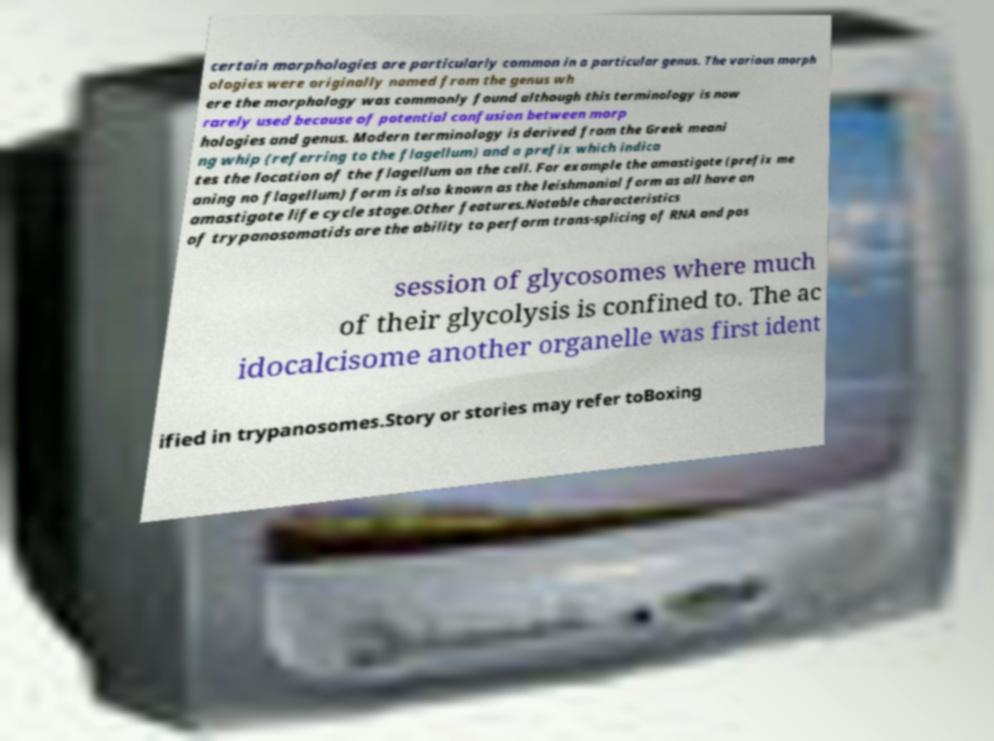I need the written content from this picture converted into text. Can you do that? certain morphologies are particularly common in a particular genus. The various morph ologies were originally named from the genus wh ere the morphology was commonly found although this terminology is now rarely used because of potential confusion between morp hologies and genus. Modern terminology is derived from the Greek meani ng whip (referring to the flagellum) and a prefix which indica tes the location of the flagellum on the cell. For example the amastigote (prefix me aning no flagellum) form is also known as the leishmanial form as all have an amastigote life cycle stage.Other features.Notable characteristics of trypanosomatids are the ability to perform trans-splicing of RNA and pos session of glycosomes where much of their glycolysis is confined to. The ac idocalcisome another organelle was first ident ified in trypanosomes.Story or stories may refer toBoxing 